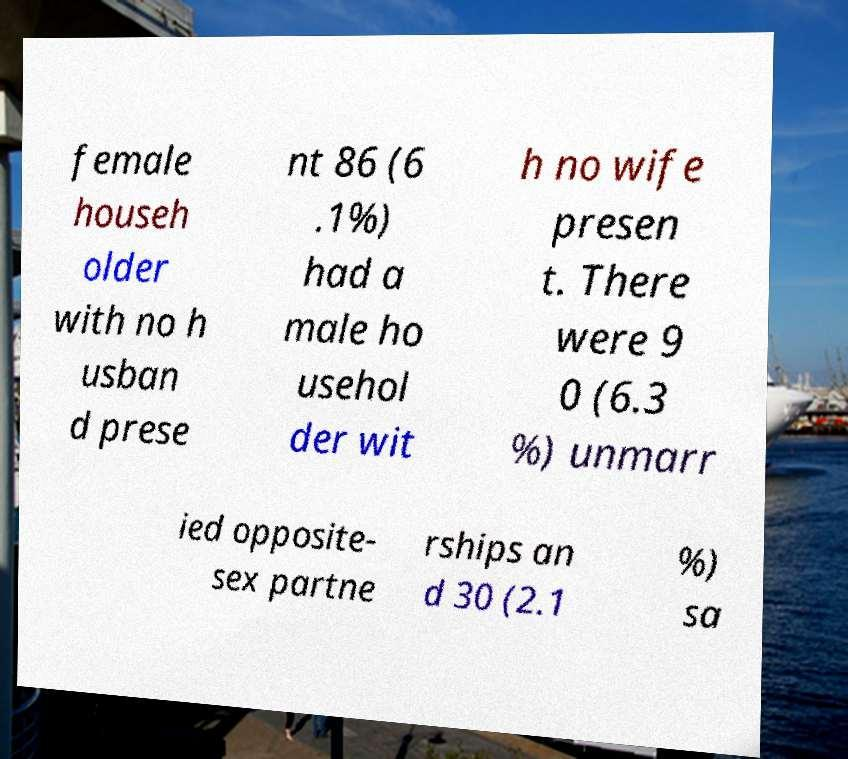Could you assist in decoding the text presented in this image and type it out clearly? female househ older with no h usban d prese nt 86 (6 .1%) had a male ho usehol der wit h no wife presen t. There were 9 0 (6.3 %) unmarr ied opposite- sex partne rships an d 30 (2.1 %) sa 